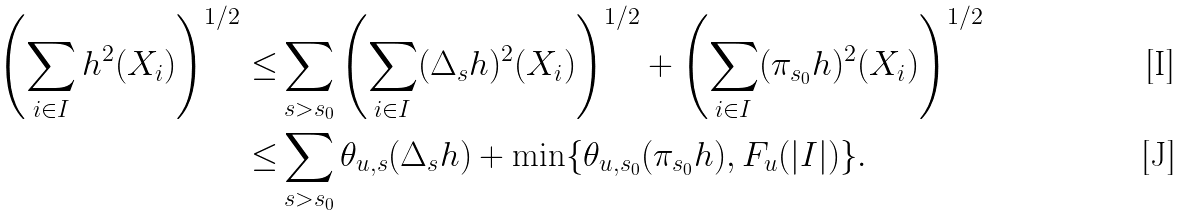<formula> <loc_0><loc_0><loc_500><loc_500>\left ( \sum _ { i \in I } h ^ { 2 } ( X _ { i } ) \right ) ^ { 1 / 2 } \leq & \sum _ { s > s _ { 0 } } \left ( \sum _ { i \in I } ( \Delta _ { s } h ) ^ { 2 } ( X _ { i } ) \right ) ^ { 1 / 2 } + \left ( \sum _ { i \in I } ( \pi _ { s _ { 0 } } h ) ^ { 2 } ( X _ { i } ) \right ) ^ { 1 / 2 } \\ \leq & \sum _ { s > s _ { 0 } } \theta _ { u , s } ( \Delta _ { s } h ) + \min \{ \theta _ { u , s _ { 0 } } ( \pi _ { s _ { 0 } } h ) , F _ { u } ( | I | ) \} .</formula> 